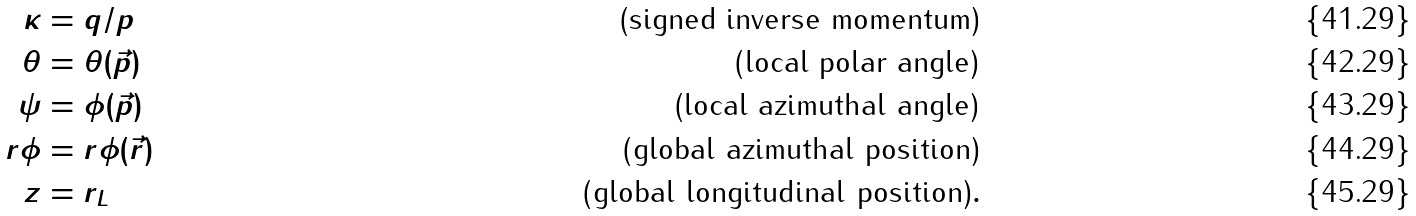<formula> <loc_0><loc_0><loc_500><loc_500>\kappa & = q / p & \text {(signed inverse momentum)} \\ \theta & = \theta ( \vec { p } ) & \text {(local polar angle)} \\ \psi & = \phi ( { \vec { p } } ) & \text {(local azimuthal angle)} \\ r \phi & = r \phi ( { \vec { r } } ) & \text {(global azimuthal position)} \\ z & = r _ { L } & \text {(global longitudinal position)} .</formula> 